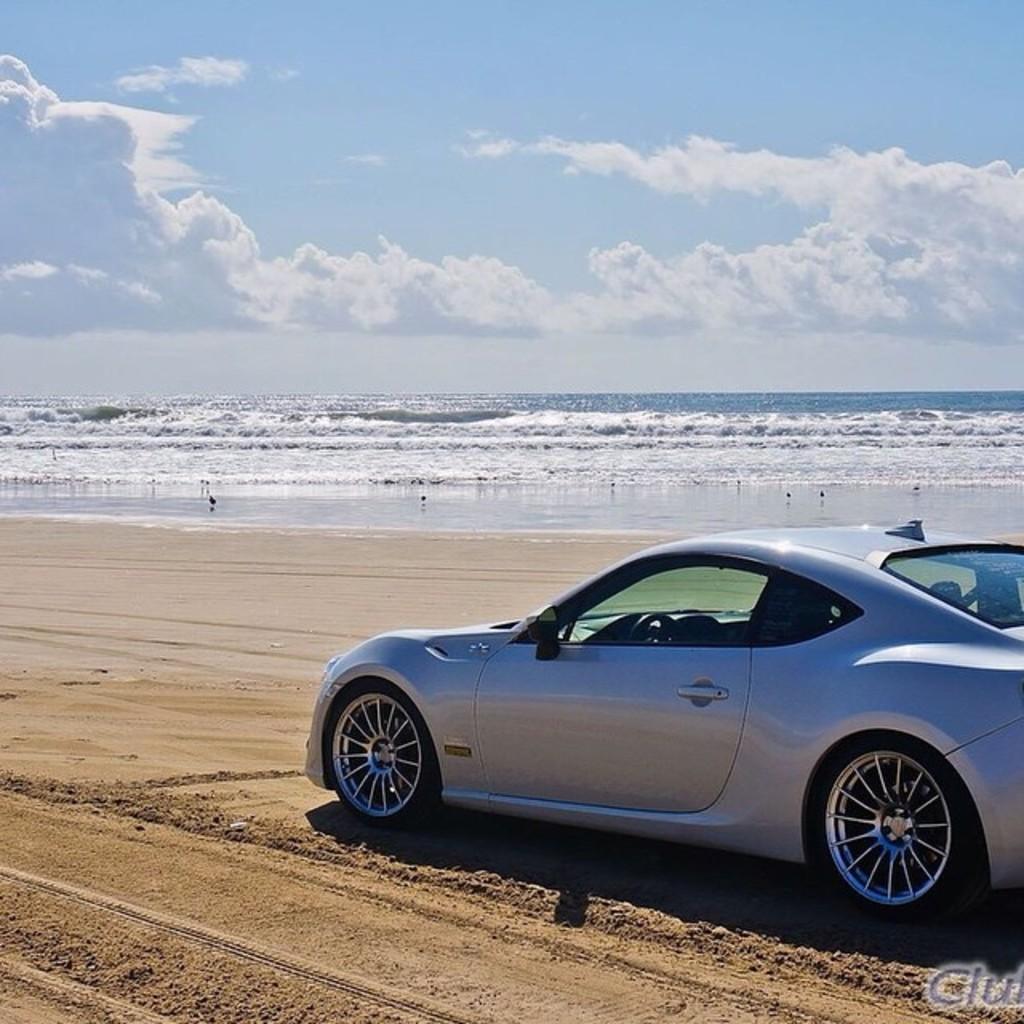In one or two sentences, can you explain what this image depicts? This image is taken outdoors. At the top of the image there is a sky with clouds. At the bottom of the image there is a ground. In the middle of the image there is a sea with waves. On the right side of the image a car is parked on the ground. 